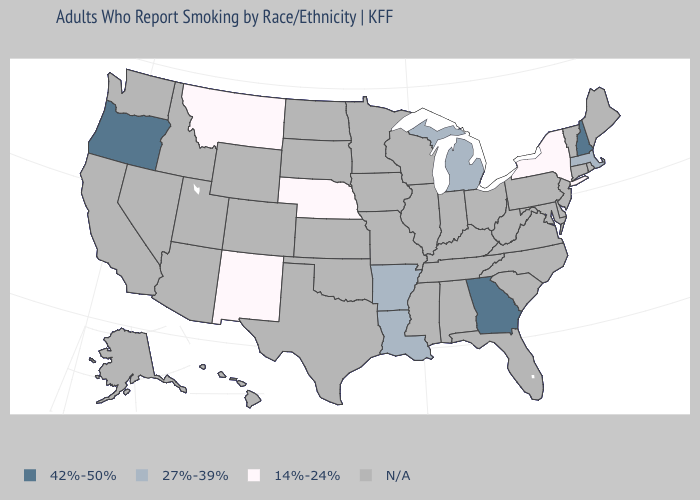What is the value of New York?
Quick response, please. 14%-24%. What is the value of New York?
Write a very short answer. 14%-24%. What is the value of Arizona?
Answer briefly. N/A. Does New Mexico have the lowest value in the West?
Be succinct. Yes. Among the states that border Arizona , which have the lowest value?
Quick response, please. New Mexico. What is the lowest value in the West?
Give a very brief answer. 14%-24%. What is the lowest value in states that border Colorado?
Short answer required. 14%-24%. What is the lowest value in the USA?
Give a very brief answer. 14%-24%. Which states have the highest value in the USA?
Write a very short answer. Georgia, New Hampshire, Oregon. What is the highest value in the USA?
Answer briefly. 42%-50%. Name the states that have a value in the range 42%-50%?
Keep it brief. Georgia, New Hampshire, Oregon. Name the states that have a value in the range N/A?
Write a very short answer. Alabama, Alaska, Arizona, California, Colorado, Connecticut, Delaware, Florida, Hawaii, Idaho, Illinois, Indiana, Iowa, Kansas, Kentucky, Maine, Maryland, Minnesota, Mississippi, Missouri, Nevada, New Jersey, North Carolina, North Dakota, Ohio, Oklahoma, Pennsylvania, Rhode Island, South Carolina, South Dakota, Tennessee, Texas, Utah, Vermont, Virginia, Washington, West Virginia, Wisconsin, Wyoming. Which states have the lowest value in the MidWest?
Concise answer only. Nebraska. What is the lowest value in the Northeast?
Give a very brief answer. 14%-24%. 